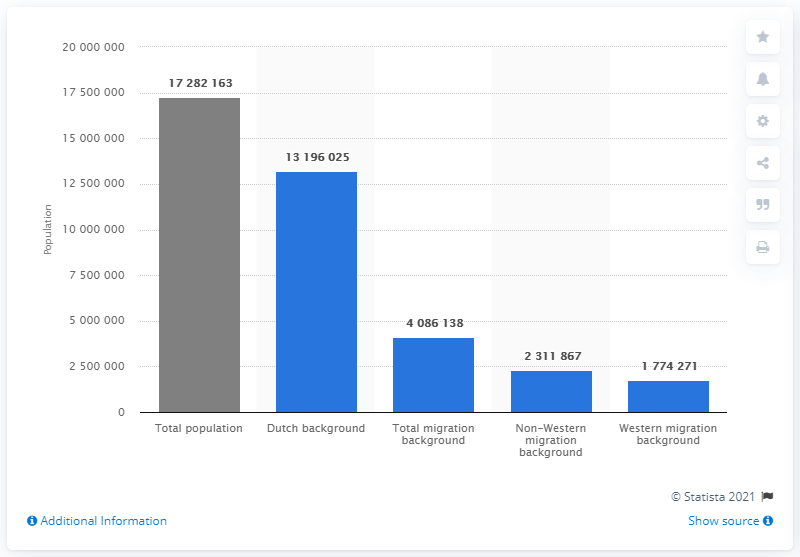Identify some key points in this picture. According to the latest available data as of January 1, 2019, approximately 13,196,025 people in the Netherlands had a Dutch background. As of January 1, 2019, it is estimated that 17,282,163 people lived in the Netherlands. 